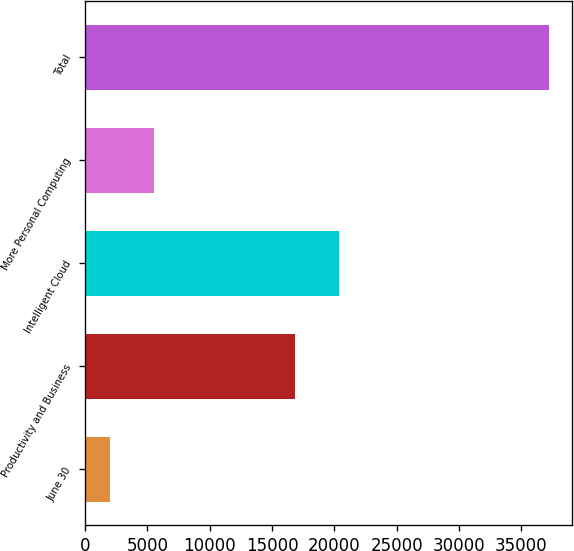<chart> <loc_0><loc_0><loc_500><loc_500><bar_chart><fcel>June 30<fcel>Productivity and Business<fcel>Intelligent Cloud<fcel>More Personal Computing<fcel>Total<nl><fcel>2019<fcel>16831<fcel>20349.7<fcel>5537.7<fcel>37206<nl></chart> 